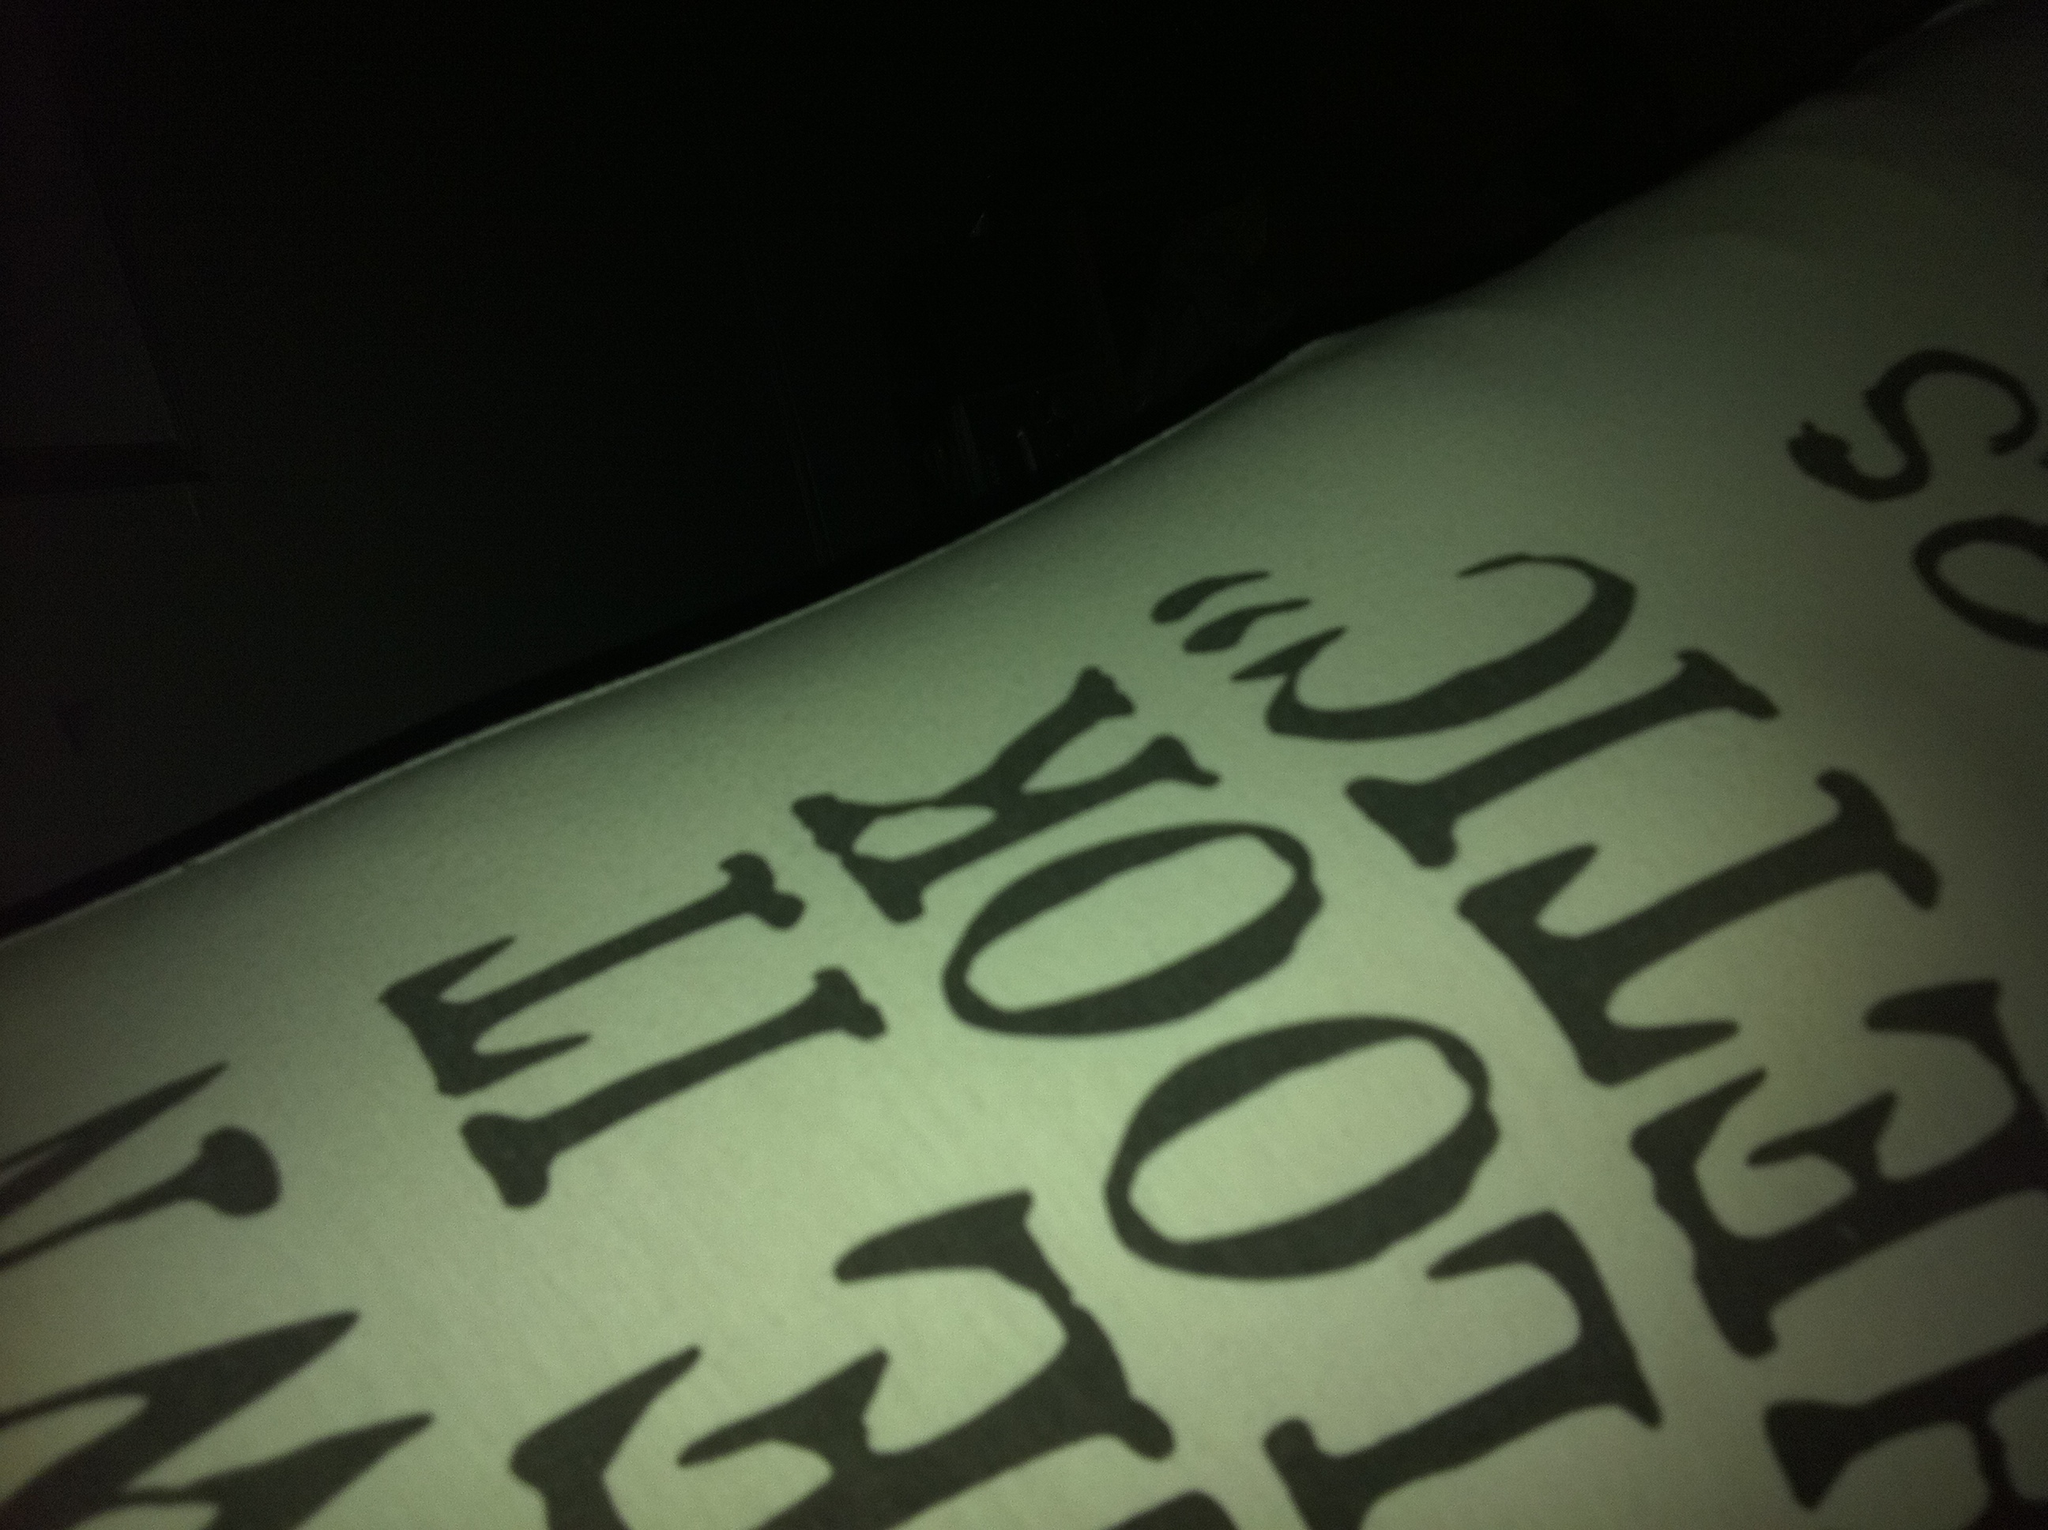Oh my God! Maybe because there are letters on it maybe that's green and maybe the back is white then. I don't know. I don't care either, but thank you anyway. I appreciate it. From the image, it seems to be a close-up shot of an object with a white background and black text printed on it. The letters appear to be part of some words or a phrase, but due to the angle and the partial view, it's hard to determine what the entire text says. 